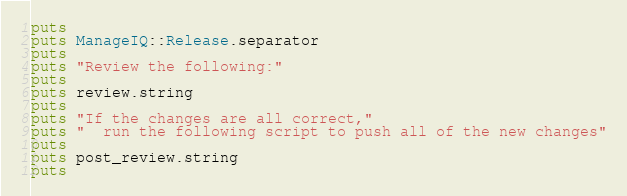<code> <loc_0><loc_0><loc_500><loc_500><_Ruby_>
puts
puts ManageIQ::Release.separator
puts
puts "Review the following:"
puts
puts review.string
puts
puts "If the changes are all correct,"
puts "  run the following script to push all of the new changes"
puts
puts post_review.string
puts
</code> 